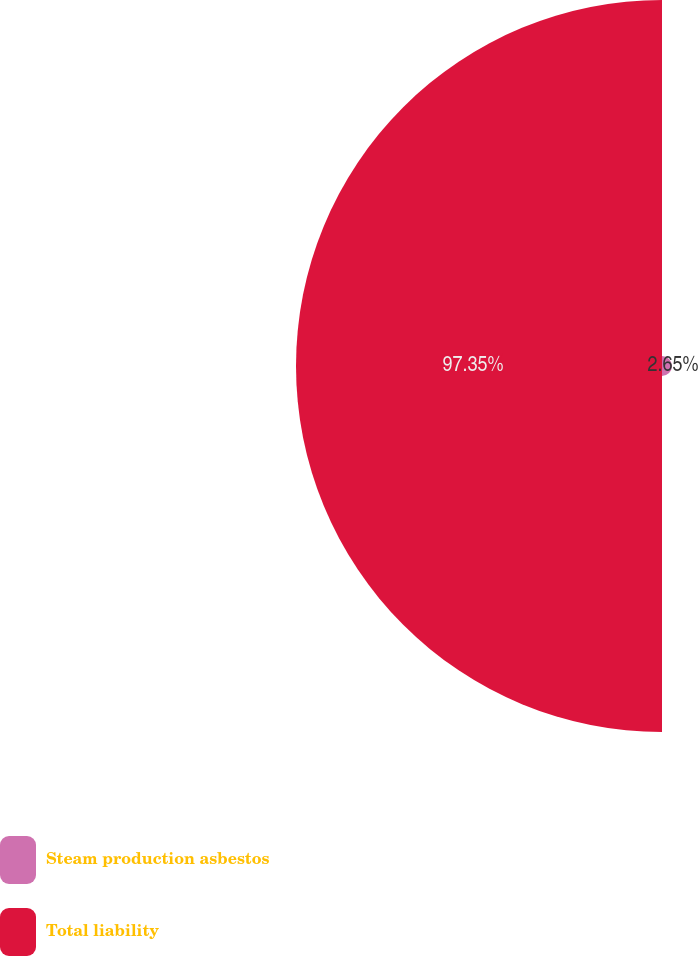Convert chart. <chart><loc_0><loc_0><loc_500><loc_500><pie_chart><fcel>Steam production asbestos<fcel>Total liability<nl><fcel>2.65%<fcel>97.35%<nl></chart> 